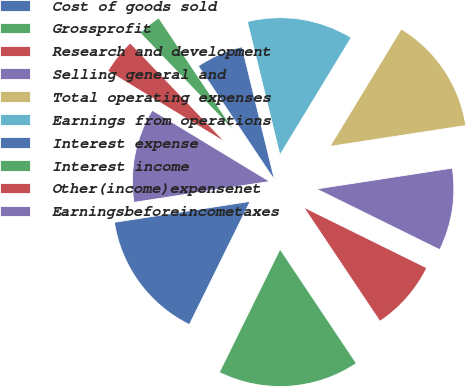Convert chart. <chart><loc_0><loc_0><loc_500><loc_500><pie_chart><fcel>Cost of goods sold<fcel>Grossprofit<fcel>Research and development<fcel>Selling general and<fcel>Total operating expenses<fcel>Earnings from operations<fcel>Interest expense<fcel>Interest income<fcel>Other(income)expensenet<fcel>Earningsbeforeincometaxes<nl><fcel>15.28%<fcel>16.67%<fcel>8.33%<fcel>9.72%<fcel>13.89%<fcel>12.5%<fcel>5.56%<fcel>2.78%<fcel>4.17%<fcel>11.11%<nl></chart> 